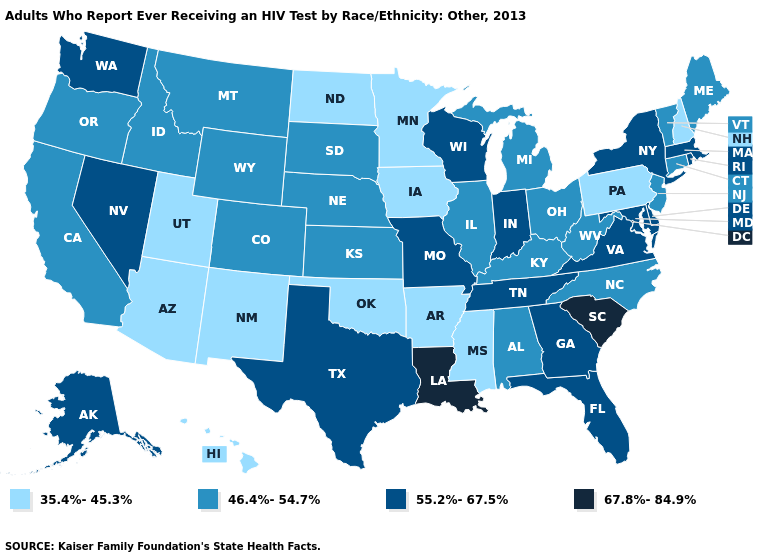Name the states that have a value in the range 35.4%-45.3%?
Give a very brief answer. Arizona, Arkansas, Hawaii, Iowa, Minnesota, Mississippi, New Hampshire, New Mexico, North Dakota, Oklahoma, Pennsylvania, Utah. Which states have the highest value in the USA?
Answer briefly. Louisiana, South Carolina. Name the states that have a value in the range 67.8%-84.9%?
Be succinct. Louisiana, South Carolina. Name the states that have a value in the range 55.2%-67.5%?
Quick response, please. Alaska, Delaware, Florida, Georgia, Indiana, Maryland, Massachusetts, Missouri, Nevada, New York, Rhode Island, Tennessee, Texas, Virginia, Washington, Wisconsin. Does Michigan have a lower value than New York?
Short answer required. Yes. Name the states that have a value in the range 67.8%-84.9%?
Be succinct. Louisiana, South Carolina. Name the states that have a value in the range 55.2%-67.5%?
Keep it brief. Alaska, Delaware, Florida, Georgia, Indiana, Maryland, Massachusetts, Missouri, Nevada, New York, Rhode Island, Tennessee, Texas, Virginia, Washington, Wisconsin. What is the lowest value in states that border South Carolina?
Answer briefly. 46.4%-54.7%. Does Louisiana have the lowest value in the USA?
Short answer required. No. Name the states that have a value in the range 46.4%-54.7%?
Concise answer only. Alabama, California, Colorado, Connecticut, Idaho, Illinois, Kansas, Kentucky, Maine, Michigan, Montana, Nebraska, New Jersey, North Carolina, Ohio, Oregon, South Dakota, Vermont, West Virginia, Wyoming. Does the map have missing data?
Be succinct. No. What is the value of Delaware?
Short answer required. 55.2%-67.5%. Name the states that have a value in the range 55.2%-67.5%?
Write a very short answer. Alaska, Delaware, Florida, Georgia, Indiana, Maryland, Massachusetts, Missouri, Nevada, New York, Rhode Island, Tennessee, Texas, Virginia, Washington, Wisconsin. What is the lowest value in states that border Oklahoma?
Keep it brief. 35.4%-45.3%. Name the states that have a value in the range 55.2%-67.5%?
Give a very brief answer. Alaska, Delaware, Florida, Georgia, Indiana, Maryland, Massachusetts, Missouri, Nevada, New York, Rhode Island, Tennessee, Texas, Virginia, Washington, Wisconsin. 